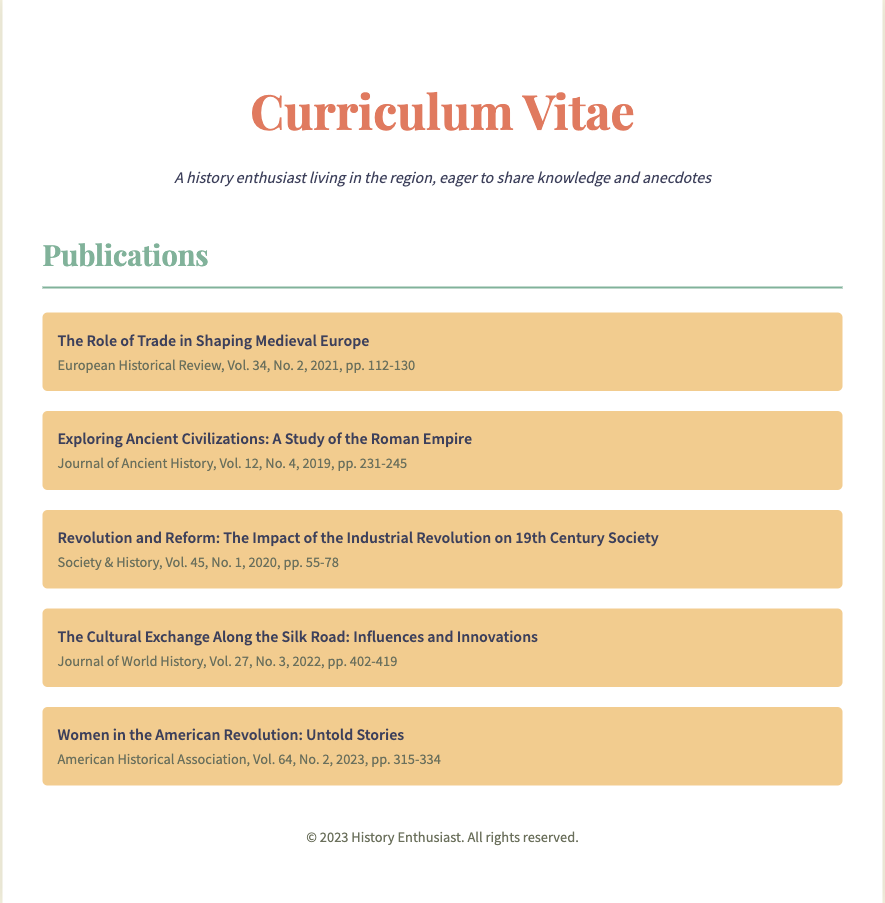What is the title of the most recent publication? The most recent publication listed is "Women in the American Revolution: Untold Stories."
Answer: Women in the American Revolution: Untold Stories What journal published the article on the Industrial Revolution? The article titled "Revolution and Reform: The Impact of the Industrial Revolution on 19th Century Society" was published in "Society & History."
Answer: Society & History In what year was "The Role of Trade in Shaping Medieval Europe" published? This publication was released in 2021.
Answer: 2021 How many articles are listed in the publication section? There are five publications listed in total.
Answer: 5 Which volume and issue features the article about the Silk Road? The article "The Cultural Exchange Along the Silk Road: Influences and Innovations" is in Volume 27, No. 3.
Answer: Volume 27, No. 3 What is the page range for the article on the Roman Empire? The article spans pages 231 to 245.
Answer: pp. 231-245 Who is the author of the publication on ancient civilizations? The document does not specify the author for this publication.
Answer: Not specified What theme do the listed publications mainly cover? The publications cover various historical themes.
Answer: Historical themes 